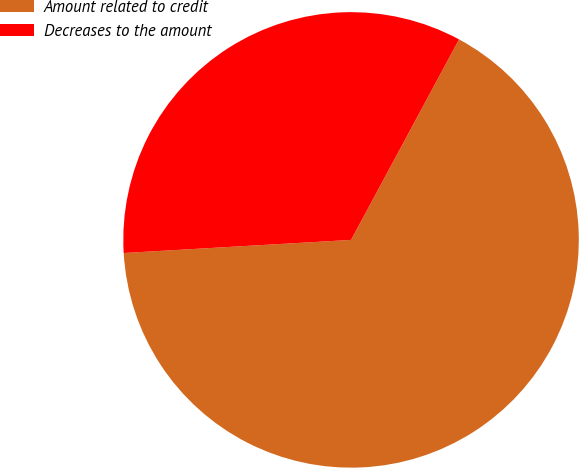<chart> <loc_0><loc_0><loc_500><loc_500><pie_chart><fcel>Amount related to credit<fcel>Decreases to the amount<nl><fcel>66.22%<fcel>33.78%<nl></chart> 